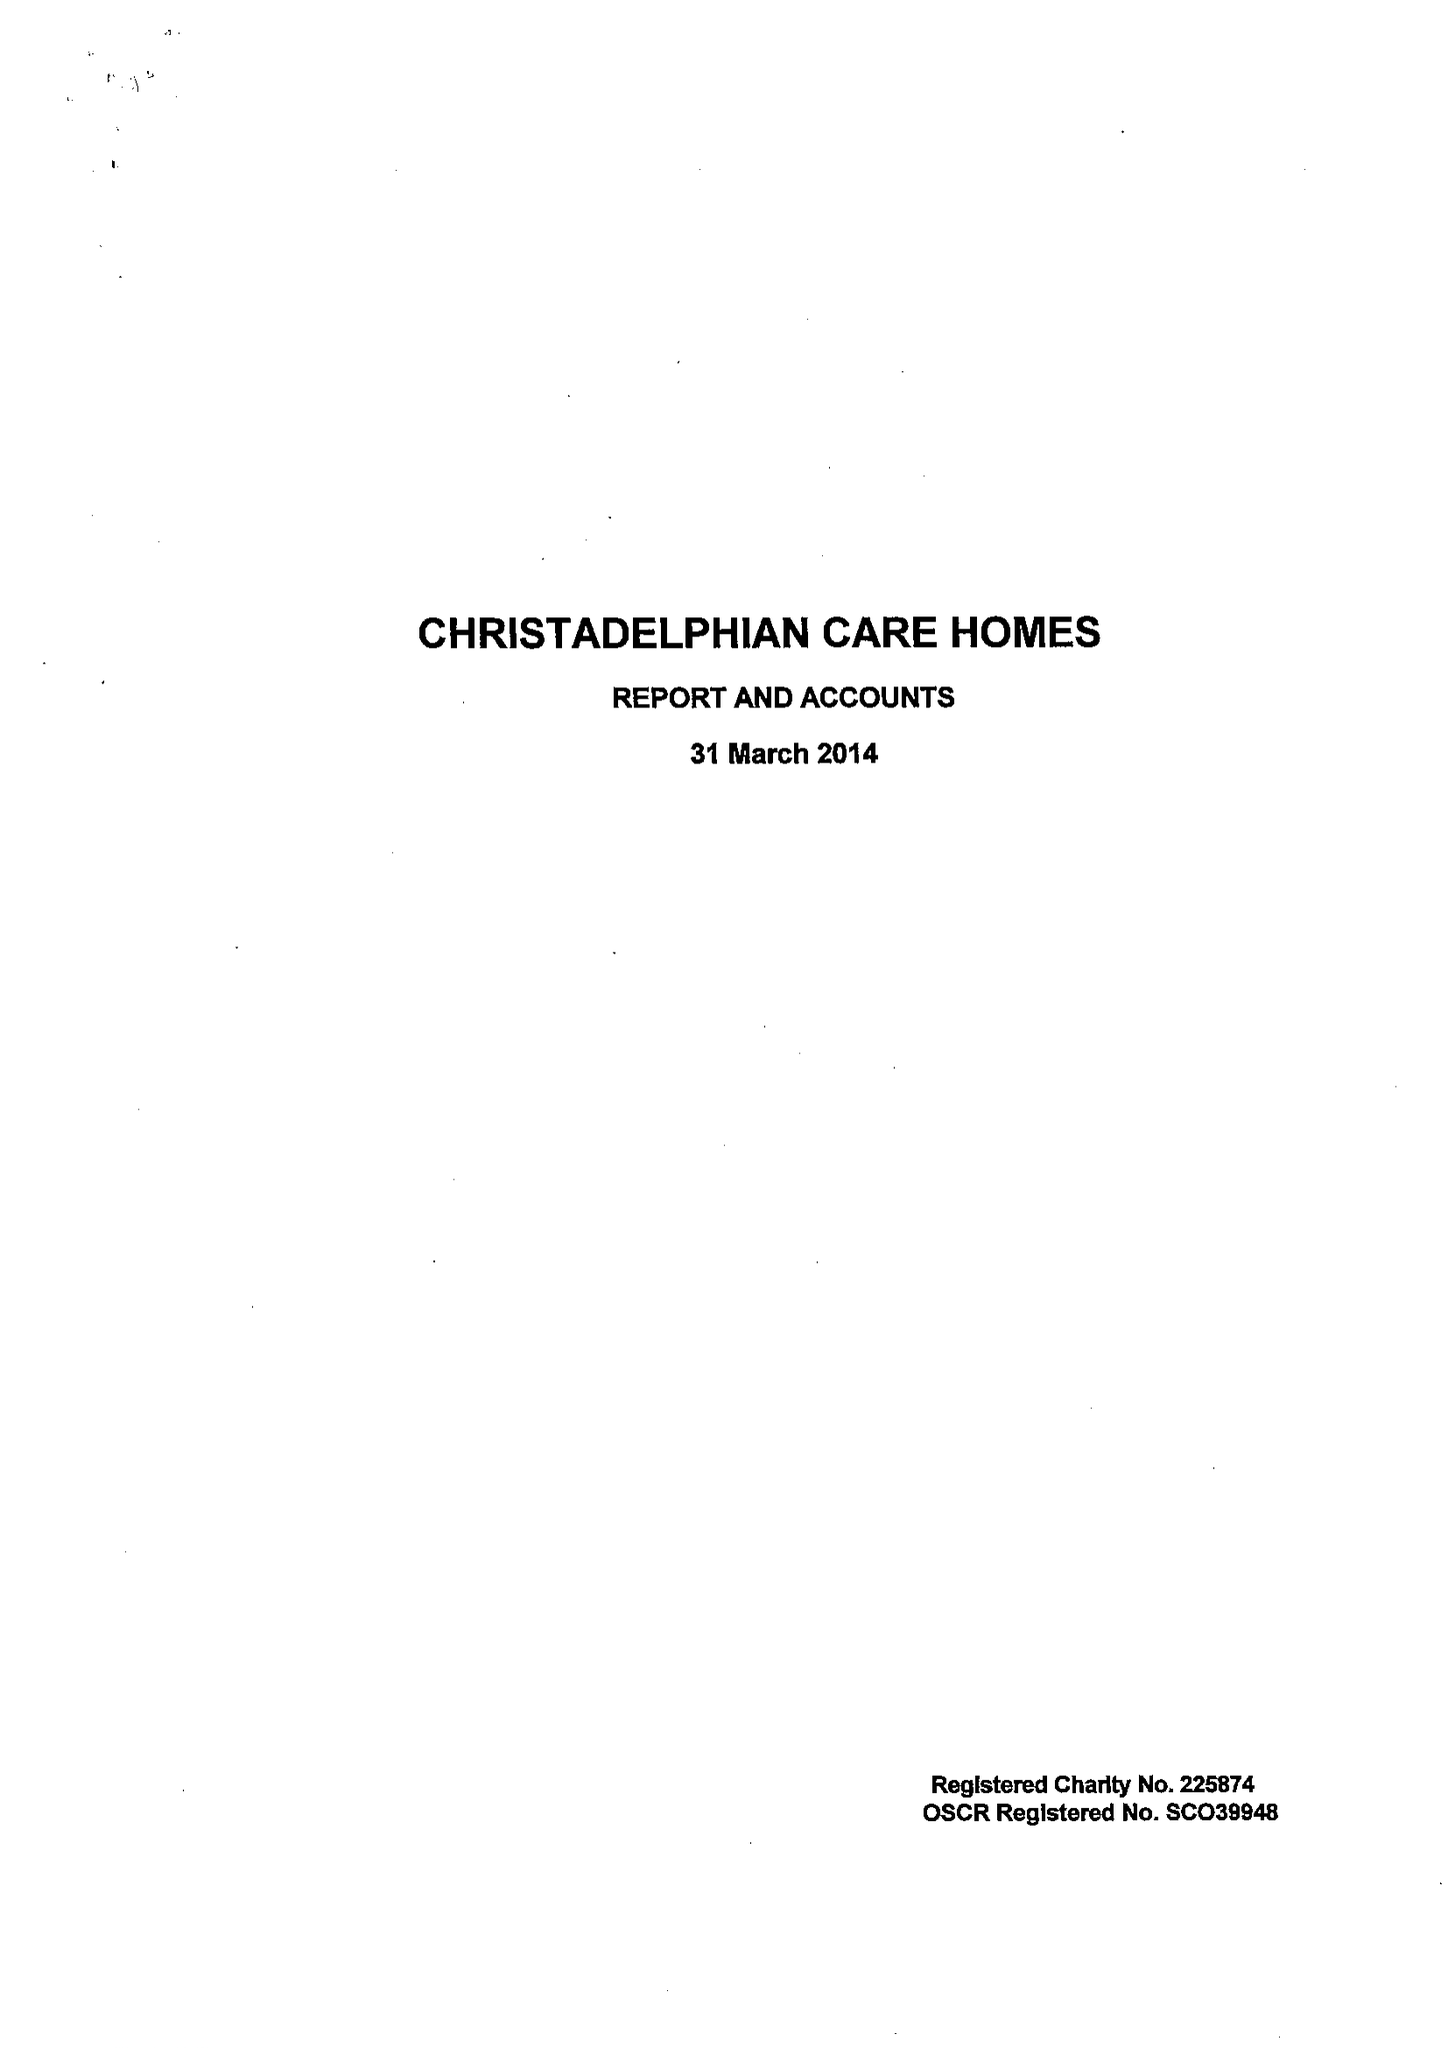What is the value for the address__post_town?
Answer the question using a single word or phrase. BIRMINGHAM 